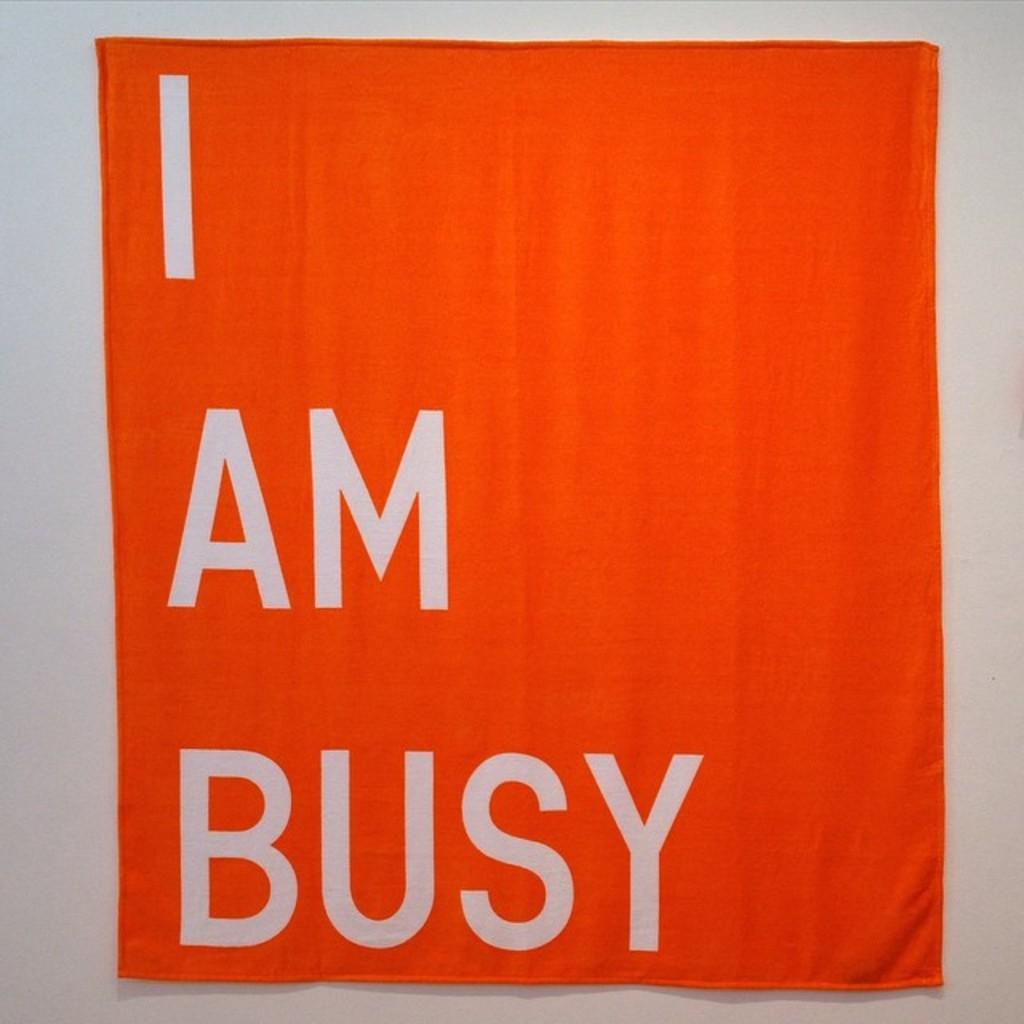What are they?
Keep it short and to the point. Busy. 